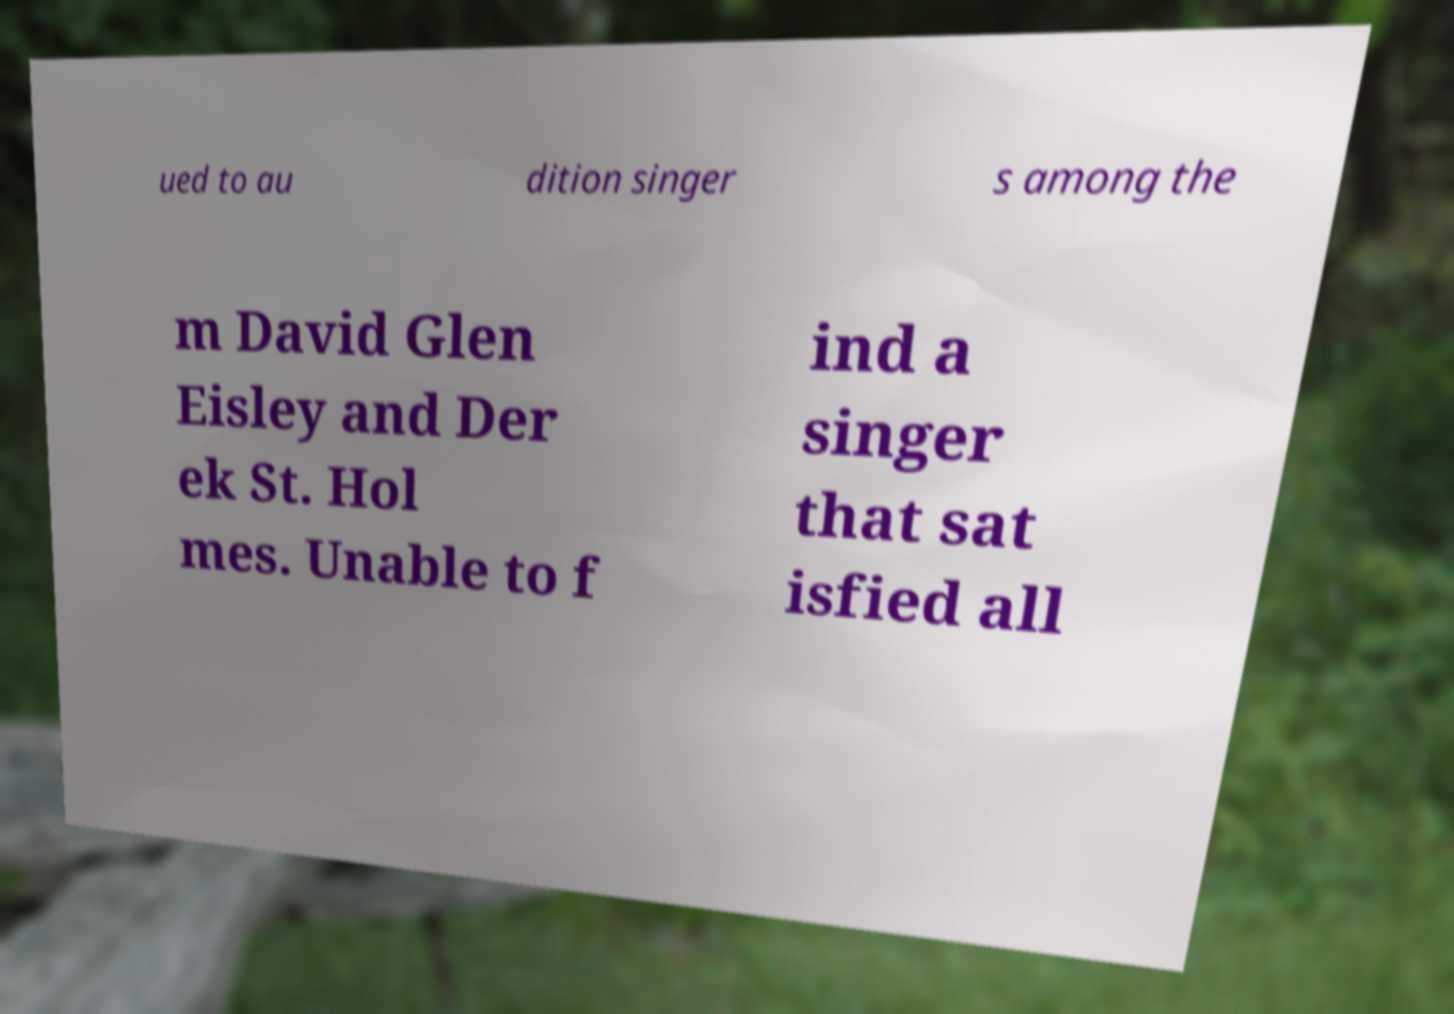Please read and relay the text visible in this image. What does it say? ued to au dition singer s among the m David Glen Eisley and Der ek St. Hol mes. Unable to f ind a singer that sat isfied all 